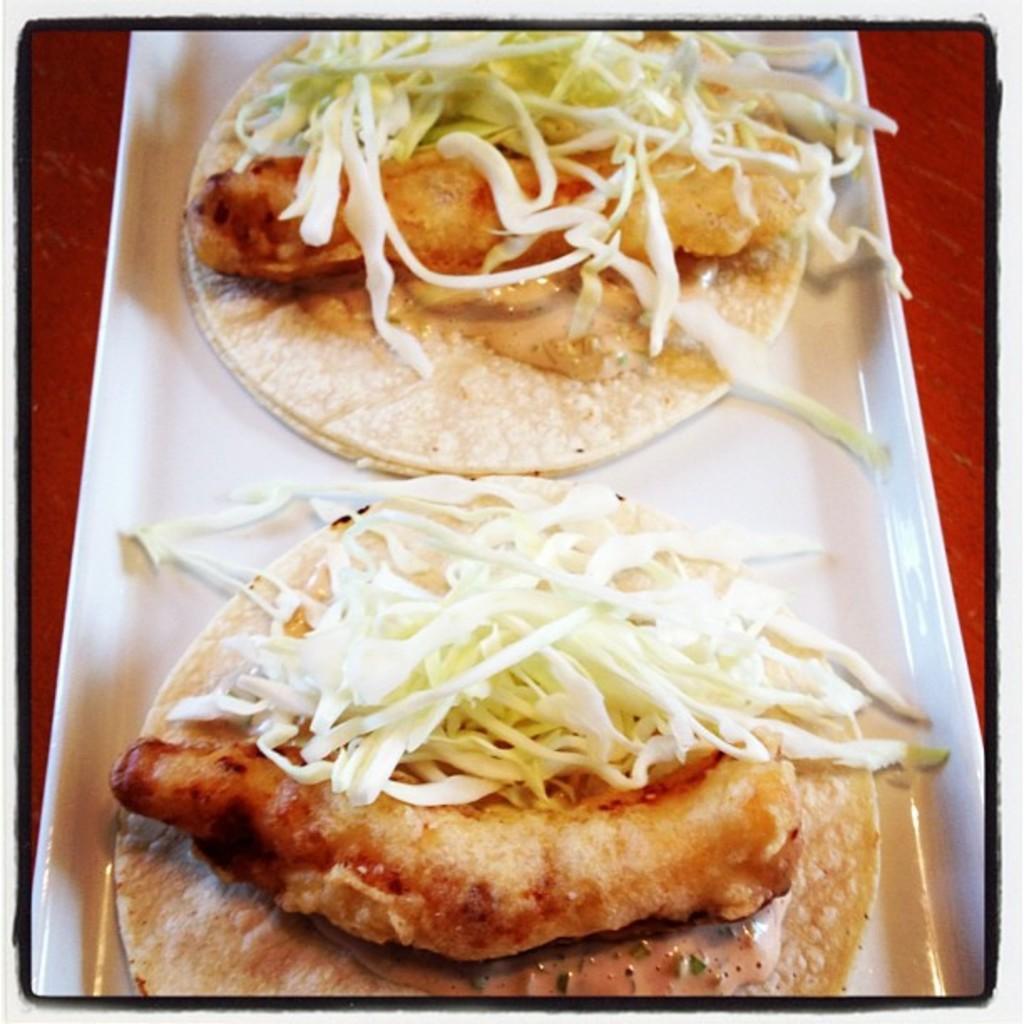How would you summarize this image in a sentence or two? In the image I can see a plate in which there is some food item. 